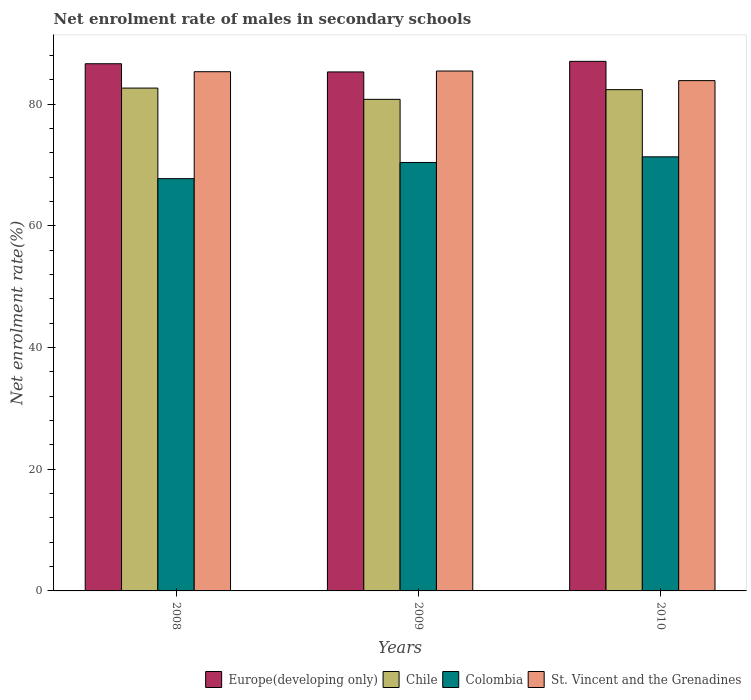How many different coloured bars are there?
Your response must be concise. 4. How many groups of bars are there?
Offer a terse response. 3. Are the number of bars per tick equal to the number of legend labels?
Give a very brief answer. Yes. Are the number of bars on each tick of the X-axis equal?
Provide a short and direct response. Yes. What is the label of the 2nd group of bars from the left?
Your response must be concise. 2009. In how many cases, is the number of bars for a given year not equal to the number of legend labels?
Keep it short and to the point. 0. What is the net enrolment rate of males in secondary schools in St. Vincent and the Grenadines in 2009?
Make the answer very short. 85.46. Across all years, what is the maximum net enrolment rate of males in secondary schools in St. Vincent and the Grenadines?
Offer a terse response. 85.46. Across all years, what is the minimum net enrolment rate of males in secondary schools in Chile?
Ensure brevity in your answer.  80.81. What is the total net enrolment rate of males in secondary schools in St. Vincent and the Grenadines in the graph?
Your answer should be compact. 254.7. What is the difference between the net enrolment rate of males in secondary schools in Chile in 2008 and that in 2010?
Offer a very short reply. 0.26. What is the difference between the net enrolment rate of males in secondary schools in Europe(developing only) in 2008 and the net enrolment rate of males in secondary schools in St. Vincent and the Grenadines in 2009?
Your answer should be very brief. 1.2. What is the average net enrolment rate of males in secondary schools in Chile per year?
Your answer should be compact. 81.96. In the year 2009, what is the difference between the net enrolment rate of males in secondary schools in Colombia and net enrolment rate of males in secondary schools in Europe(developing only)?
Give a very brief answer. -14.88. What is the ratio of the net enrolment rate of males in secondary schools in St. Vincent and the Grenadines in 2009 to that in 2010?
Make the answer very short. 1.02. Is the net enrolment rate of males in secondary schools in Colombia in 2009 less than that in 2010?
Your response must be concise. Yes. What is the difference between the highest and the second highest net enrolment rate of males in secondary schools in St. Vincent and the Grenadines?
Make the answer very short. 0.11. What is the difference between the highest and the lowest net enrolment rate of males in secondary schools in Europe(developing only)?
Make the answer very short. 1.74. Is the sum of the net enrolment rate of males in secondary schools in St. Vincent and the Grenadines in 2009 and 2010 greater than the maximum net enrolment rate of males in secondary schools in Chile across all years?
Offer a terse response. Yes. Is it the case that in every year, the sum of the net enrolment rate of males in secondary schools in Colombia and net enrolment rate of males in secondary schools in Europe(developing only) is greater than the sum of net enrolment rate of males in secondary schools in St. Vincent and the Grenadines and net enrolment rate of males in secondary schools in Chile?
Provide a short and direct response. No. What does the 4th bar from the left in 2008 represents?
Ensure brevity in your answer.  St. Vincent and the Grenadines. What does the 2nd bar from the right in 2009 represents?
Keep it short and to the point. Colombia. How many years are there in the graph?
Ensure brevity in your answer.  3. What is the difference between two consecutive major ticks on the Y-axis?
Offer a very short reply. 20. How many legend labels are there?
Your answer should be compact. 4. What is the title of the graph?
Ensure brevity in your answer.  Net enrolment rate of males in secondary schools. Does "Qatar" appear as one of the legend labels in the graph?
Offer a very short reply. No. What is the label or title of the X-axis?
Your answer should be very brief. Years. What is the label or title of the Y-axis?
Your answer should be very brief. Net enrolment rate(%). What is the Net enrolment rate(%) in Europe(developing only) in 2008?
Provide a succinct answer. 86.66. What is the Net enrolment rate(%) in Chile in 2008?
Give a very brief answer. 82.66. What is the Net enrolment rate(%) in Colombia in 2008?
Offer a very short reply. 67.77. What is the Net enrolment rate(%) in St. Vincent and the Grenadines in 2008?
Your answer should be compact. 85.35. What is the Net enrolment rate(%) in Europe(developing only) in 2009?
Offer a terse response. 85.31. What is the Net enrolment rate(%) of Chile in 2009?
Offer a very short reply. 80.81. What is the Net enrolment rate(%) in Colombia in 2009?
Make the answer very short. 70.43. What is the Net enrolment rate(%) of St. Vincent and the Grenadines in 2009?
Your answer should be very brief. 85.46. What is the Net enrolment rate(%) of Europe(developing only) in 2010?
Your answer should be very brief. 87.05. What is the Net enrolment rate(%) of Chile in 2010?
Your answer should be compact. 82.4. What is the Net enrolment rate(%) of Colombia in 2010?
Provide a short and direct response. 71.36. What is the Net enrolment rate(%) of St. Vincent and the Grenadines in 2010?
Keep it short and to the point. 83.89. Across all years, what is the maximum Net enrolment rate(%) of Europe(developing only)?
Your response must be concise. 87.05. Across all years, what is the maximum Net enrolment rate(%) in Chile?
Keep it short and to the point. 82.66. Across all years, what is the maximum Net enrolment rate(%) in Colombia?
Offer a terse response. 71.36. Across all years, what is the maximum Net enrolment rate(%) of St. Vincent and the Grenadines?
Your answer should be compact. 85.46. Across all years, what is the minimum Net enrolment rate(%) in Europe(developing only)?
Give a very brief answer. 85.31. Across all years, what is the minimum Net enrolment rate(%) of Chile?
Provide a succinct answer. 80.81. Across all years, what is the minimum Net enrolment rate(%) in Colombia?
Make the answer very short. 67.77. Across all years, what is the minimum Net enrolment rate(%) of St. Vincent and the Grenadines?
Your response must be concise. 83.89. What is the total Net enrolment rate(%) in Europe(developing only) in the graph?
Offer a terse response. 259.03. What is the total Net enrolment rate(%) in Chile in the graph?
Give a very brief answer. 245.87. What is the total Net enrolment rate(%) of Colombia in the graph?
Ensure brevity in your answer.  209.56. What is the total Net enrolment rate(%) in St. Vincent and the Grenadines in the graph?
Ensure brevity in your answer.  254.7. What is the difference between the Net enrolment rate(%) in Europe(developing only) in 2008 and that in 2009?
Offer a terse response. 1.35. What is the difference between the Net enrolment rate(%) of Chile in 2008 and that in 2009?
Ensure brevity in your answer.  1.85. What is the difference between the Net enrolment rate(%) of Colombia in 2008 and that in 2009?
Offer a terse response. -2.66. What is the difference between the Net enrolment rate(%) of St. Vincent and the Grenadines in 2008 and that in 2009?
Give a very brief answer. -0.11. What is the difference between the Net enrolment rate(%) in Europe(developing only) in 2008 and that in 2010?
Offer a very short reply. -0.39. What is the difference between the Net enrolment rate(%) of Chile in 2008 and that in 2010?
Make the answer very short. 0.26. What is the difference between the Net enrolment rate(%) in Colombia in 2008 and that in 2010?
Your answer should be very brief. -3.59. What is the difference between the Net enrolment rate(%) in St. Vincent and the Grenadines in 2008 and that in 2010?
Your answer should be compact. 1.47. What is the difference between the Net enrolment rate(%) in Europe(developing only) in 2009 and that in 2010?
Offer a very short reply. -1.74. What is the difference between the Net enrolment rate(%) of Chile in 2009 and that in 2010?
Offer a very short reply. -1.59. What is the difference between the Net enrolment rate(%) in Colombia in 2009 and that in 2010?
Give a very brief answer. -0.93. What is the difference between the Net enrolment rate(%) in St. Vincent and the Grenadines in 2009 and that in 2010?
Keep it short and to the point. 1.58. What is the difference between the Net enrolment rate(%) in Europe(developing only) in 2008 and the Net enrolment rate(%) in Chile in 2009?
Your answer should be compact. 5.85. What is the difference between the Net enrolment rate(%) in Europe(developing only) in 2008 and the Net enrolment rate(%) in Colombia in 2009?
Your answer should be compact. 16.23. What is the difference between the Net enrolment rate(%) of Europe(developing only) in 2008 and the Net enrolment rate(%) of St. Vincent and the Grenadines in 2009?
Ensure brevity in your answer.  1.2. What is the difference between the Net enrolment rate(%) in Chile in 2008 and the Net enrolment rate(%) in Colombia in 2009?
Provide a short and direct response. 12.23. What is the difference between the Net enrolment rate(%) in Chile in 2008 and the Net enrolment rate(%) in St. Vincent and the Grenadines in 2009?
Your answer should be very brief. -2.8. What is the difference between the Net enrolment rate(%) of Colombia in 2008 and the Net enrolment rate(%) of St. Vincent and the Grenadines in 2009?
Offer a very short reply. -17.69. What is the difference between the Net enrolment rate(%) of Europe(developing only) in 2008 and the Net enrolment rate(%) of Chile in 2010?
Your answer should be compact. 4.26. What is the difference between the Net enrolment rate(%) in Europe(developing only) in 2008 and the Net enrolment rate(%) in Colombia in 2010?
Keep it short and to the point. 15.3. What is the difference between the Net enrolment rate(%) of Europe(developing only) in 2008 and the Net enrolment rate(%) of St. Vincent and the Grenadines in 2010?
Offer a terse response. 2.77. What is the difference between the Net enrolment rate(%) of Chile in 2008 and the Net enrolment rate(%) of Colombia in 2010?
Give a very brief answer. 11.3. What is the difference between the Net enrolment rate(%) of Chile in 2008 and the Net enrolment rate(%) of St. Vincent and the Grenadines in 2010?
Offer a very short reply. -1.23. What is the difference between the Net enrolment rate(%) of Colombia in 2008 and the Net enrolment rate(%) of St. Vincent and the Grenadines in 2010?
Make the answer very short. -16.12. What is the difference between the Net enrolment rate(%) in Europe(developing only) in 2009 and the Net enrolment rate(%) in Chile in 2010?
Your response must be concise. 2.91. What is the difference between the Net enrolment rate(%) of Europe(developing only) in 2009 and the Net enrolment rate(%) of Colombia in 2010?
Offer a terse response. 13.96. What is the difference between the Net enrolment rate(%) in Europe(developing only) in 2009 and the Net enrolment rate(%) in St. Vincent and the Grenadines in 2010?
Offer a very short reply. 1.43. What is the difference between the Net enrolment rate(%) in Chile in 2009 and the Net enrolment rate(%) in Colombia in 2010?
Make the answer very short. 9.45. What is the difference between the Net enrolment rate(%) of Chile in 2009 and the Net enrolment rate(%) of St. Vincent and the Grenadines in 2010?
Offer a very short reply. -3.08. What is the difference between the Net enrolment rate(%) in Colombia in 2009 and the Net enrolment rate(%) in St. Vincent and the Grenadines in 2010?
Your answer should be compact. -13.46. What is the average Net enrolment rate(%) of Europe(developing only) per year?
Provide a succinct answer. 86.34. What is the average Net enrolment rate(%) of Chile per year?
Make the answer very short. 81.96. What is the average Net enrolment rate(%) in Colombia per year?
Give a very brief answer. 69.85. What is the average Net enrolment rate(%) of St. Vincent and the Grenadines per year?
Give a very brief answer. 84.9. In the year 2008, what is the difference between the Net enrolment rate(%) of Europe(developing only) and Net enrolment rate(%) of Chile?
Give a very brief answer. 4. In the year 2008, what is the difference between the Net enrolment rate(%) in Europe(developing only) and Net enrolment rate(%) in Colombia?
Keep it short and to the point. 18.89. In the year 2008, what is the difference between the Net enrolment rate(%) in Europe(developing only) and Net enrolment rate(%) in St. Vincent and the Grenadines?
Offer a very short reply. 1.31. In the year 2008, what is the difference between the Net enrolment rate(%) of Chile and Net enrolment rate(%) of Colombia?
Ensure brevity in your answer.  14.89. In the year 2008, what is the difference between the Net enrolment rate(%) of Chile and Net enrolment rate(%) of St. Vincent and the Grenadines?
Ensure brevity in your answer.  -2.69. In the year 2008, what is the difference between the Net enrolment rate(%) in Colombia and Net enrolment rate(%) in St. Vincent and the Grenadines?
Keep it short and to the point. -17.58. In the year 2009, what is the difference between the Net enrolment rate(%) in Europe(developing only) and Net enrolment rate(%) in Chile?
Provide a short and direct response. 4.5. In the year 2009, what is the difference between the Net enrolment rate(%) in Europe(developing only) and Net enrolment rate(%) in Colombia?
Your answer should be very brief. 14.88. In the year 2009, what is the difference between the Net enrolment rate(%) of Europe(developing only) and Net enrolment rate(%) of St. Vincent and the Grenadines?
Your response must be concise. -0.15. In the year 2009, what is the difference between the Net enrolment rate(%) of Chile and Net enrolment rate(%) of Colombia?
Keep it short and to the point. 10.38. In the year 2009, what is the difference between the Net enrolment rate(%) in Chile and Net enrolment rate(%) in St. Vincent and the Grenadines?
Your answer should be very brief. -4.65. In the year 2009, what is the difference between the Net enrolment rate(%) in Colombia and Net enrolment rate(%) in St. Vincent and the Grenadines?
Provide a succinct answer. -15.03. In the year 2010, what is the difference between the Net enrolment rate(%) of Europe(developing only) and Net enrolment rate(%) of Chile?
Make the answer very short. 4.65. In the year 2010, what is the difference between the Net enrolment rate(%) of Europe(developing only) and Net enrolment rate(%) of Colombia?
Offer a terse response. 15.69. In the year 2010, what is the difference between the Net enrolment rate(%) of Europe(developing only) and Net enrolment rate(%) of St. Vincent and the Grenadines?
Provide a succinct answer. 3.17. In the year 2010, what is the difference between the Net enrolment rate(%) of Chile and Net enrolment rate(%) of Colombia?
Provide a succinct answer. 11.04. In the year 2010, what is the difference between the Net enrolment rate(%) in Chile and Net enrolment rate(%) in St. Vincent and the Grenadines?
Give a very brief answer. -1.48. In the year 2010, what is the difference between the Net enrolment rate(%) of Colombia and Net enrolment rate(%) of St. Vincent and the Grenadines?
Keep it short and to the point. -12.53. What is the ratio of the Net enrolment rate(%) of Europe(developing only) in 2008 to that in 2009?
Ensure brevity in your answer.  1.02. What is the ratio of the Net enrolment rate(%) in Chile in 2008 to that in 2009?
Ensure brevity in your answer.  1.02. What is the ratio of the Net enrolment rate(%) in Colombia in 2008 to that in 2009?
Offer a very short reply. 0.96. What is the ratio of the Net enrolment rate(%) of Chile in 2008 to that in 2010?
Ensure brevity in your answer.  1. What is the ratio of the Net enrolment rate(%) in Colombia in 2008 to that in 2010?
Your answer should be very brief. 0.95. What is the ratio of the Net enrolment rate(%) of St. Vincent and the Grenadines in 2008 to that in 2010?
Provide a succinct answer. 1.02. What is the ratio of the Net enrolment rate(%) in Europe(developing only) in 2009 to that in 2010?
Your response must be concise. 0.98. What is the ratio of the Net enrolment rate(%) of Chile in 2009 to that in 2010?
Give a very brief answer. 0.98. What is the ratio of the Net enrolment rate(%) in Colombia in 2009 to that in 2010?
Your answer should be very brief. 0.99. What is the ratio of the Net enrolment rate(%) in St. Vincent and the Grenadines in 2009 to that in 2010?
Offer a terse response. 1.02. What is the difference between the highest and the second highest Net enrolment rate(%) of Europe(developing only)?
Provide a succinct answer. 0.39. What is the difference between the highest and the second highest Net enrolment rate(%) in Chile?
Keep it short and to the point. 0.26. What is the difference between the highest and the second highest Net enrolment rate(%) in Colombia?
Your answer should be very brief. 0.93. What is the difference between the highest and the second highest Net enrolment rate(%) of St. Vincent and the Grenadines?
Ensure brevity in your answer.  0.11. What is the difference between the highest and the lowest Net enrolment rate(%) of Europe(developing only)?
Your answer should be compact. 1.74. What is the difference between the highest and the lowest Net enrolment rate(%) of Chile?
Your response must be concise. 1.85. What is the difference between the highest and the lowest Net enrolment rate(%) of Colombia?
Give a very brief answer. 3.59. What is the difference between the highest and the lowest Net enrolment rate(%) in St. Vincent and the Grenadines?
Your response must be concise. 1.58. 